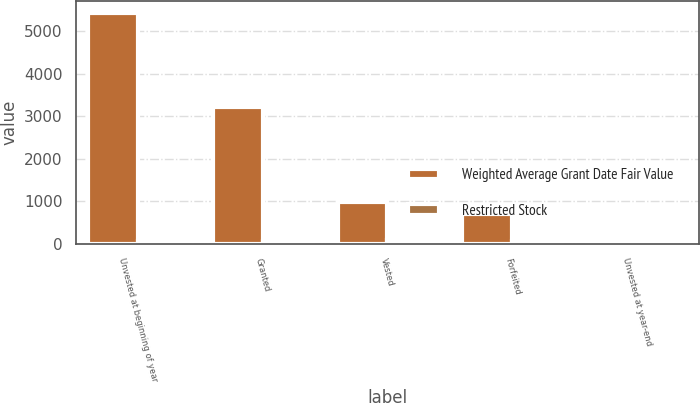<chart> <loc_0><loc_0><loc_500><loc_500><stacked_bar_chart><ecel><fcel>Unvested at beginning of year<fcel>Granted<fcel>Vested<fcel>Forfeited<fcel>Unvested at year-end<nl><fcel>Weighted Average Grant Date Fair Value<fcel>5428<fcel>3204<fcel>982<fcel>699<fcel>77.62<nl><fcel>Restricted Stock<fcel>72.33<fcel>70.54<fcel>77.62<fcel>70.67<fcel>70.13<nl></chart> 